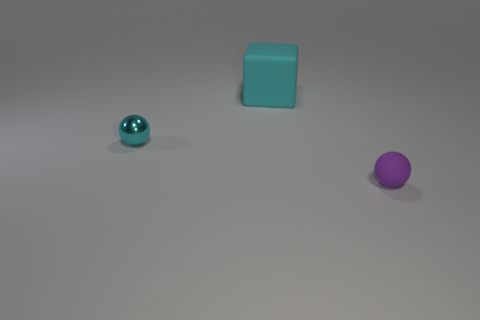Is there anything else that has the same size as the cyan matte object?
Your answer should be compact. No. Are there any other things that have the same material as the tiny cyan thing?
Provide a succinct answer. No. Do the small metal object and the small matte sphere have the same color?
Provide a succinct answer. No. Is the number of large rubber objects greater than the number of objects?
Your answer should be very brief. No. How many other things are there of the same color as the big matte thing?
Your answer should be compact. 1. There is a sphere right of the cyan rubber block; how many tiny metallic balls are behind it?
Your response must be concise. 1. There is a purple matte thing; are there any tiny purple rubber things on the left side of it?
Keep it short and to the point. No. What is the shape of the cyan object behind the cyan object left of the big rubber cube?
Your response must be concise. Cube. Are there fewer matte objects to the left of the large thing than cyan matte things on the right side of the shiny ball?
Make the answer very short. Yes. There is another small object that is the same shape as the cyan metal thing; what color is it?
Give a very brief answer. Purple. 